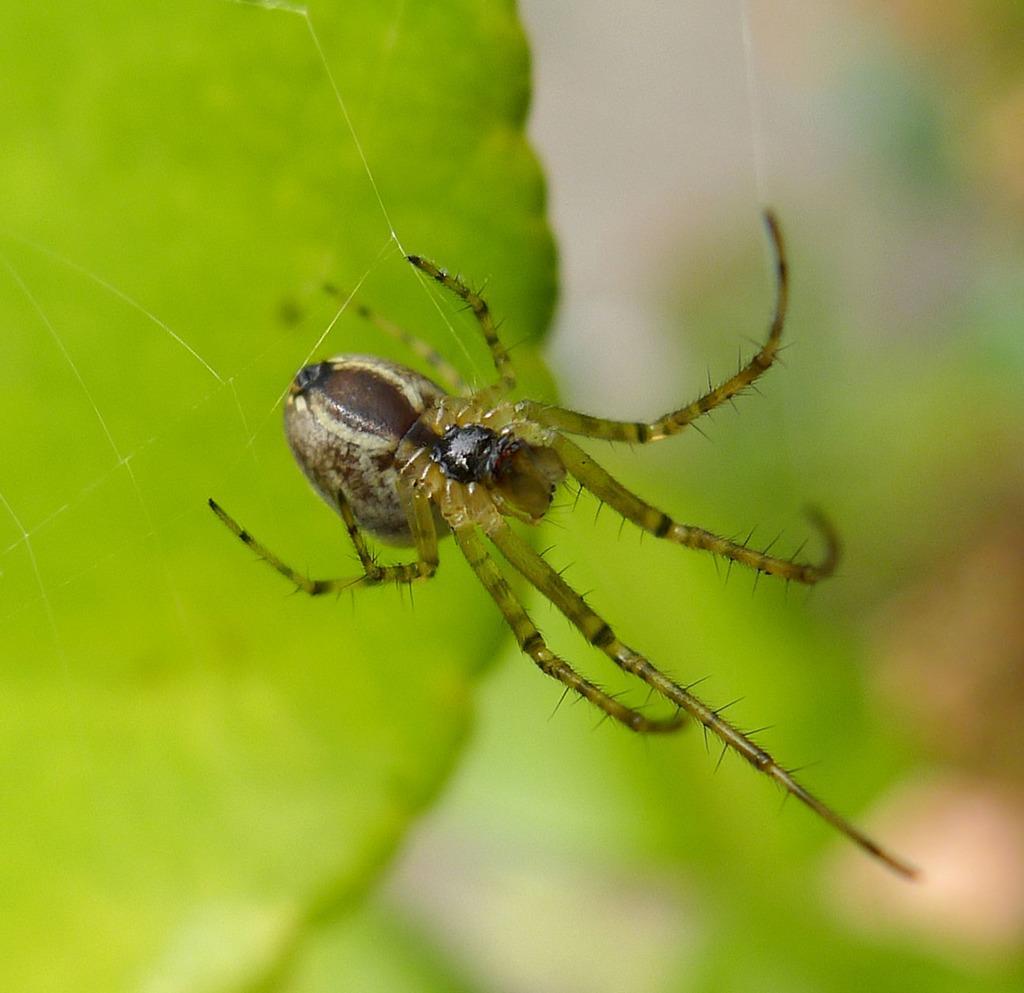How would you summarize this image in a sentence or two? In this image, we can see an insect on the leaf and the background is blurry. 